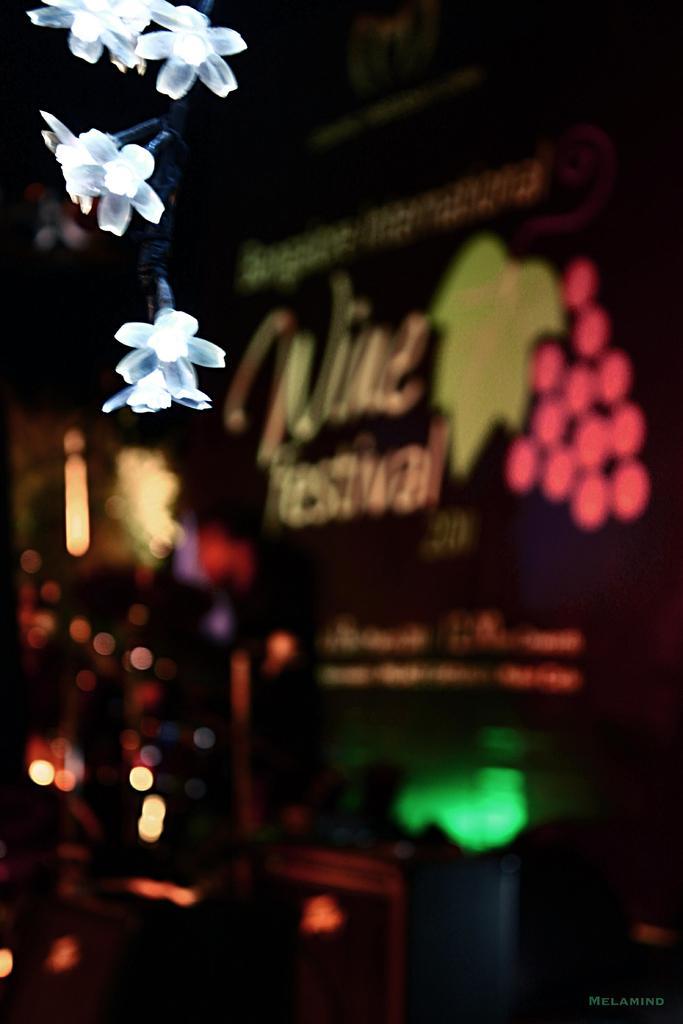Please provide a concise description of this image. In this picture we can see few flower lights in the front, in the background there is some text, we can see a blurry background. 